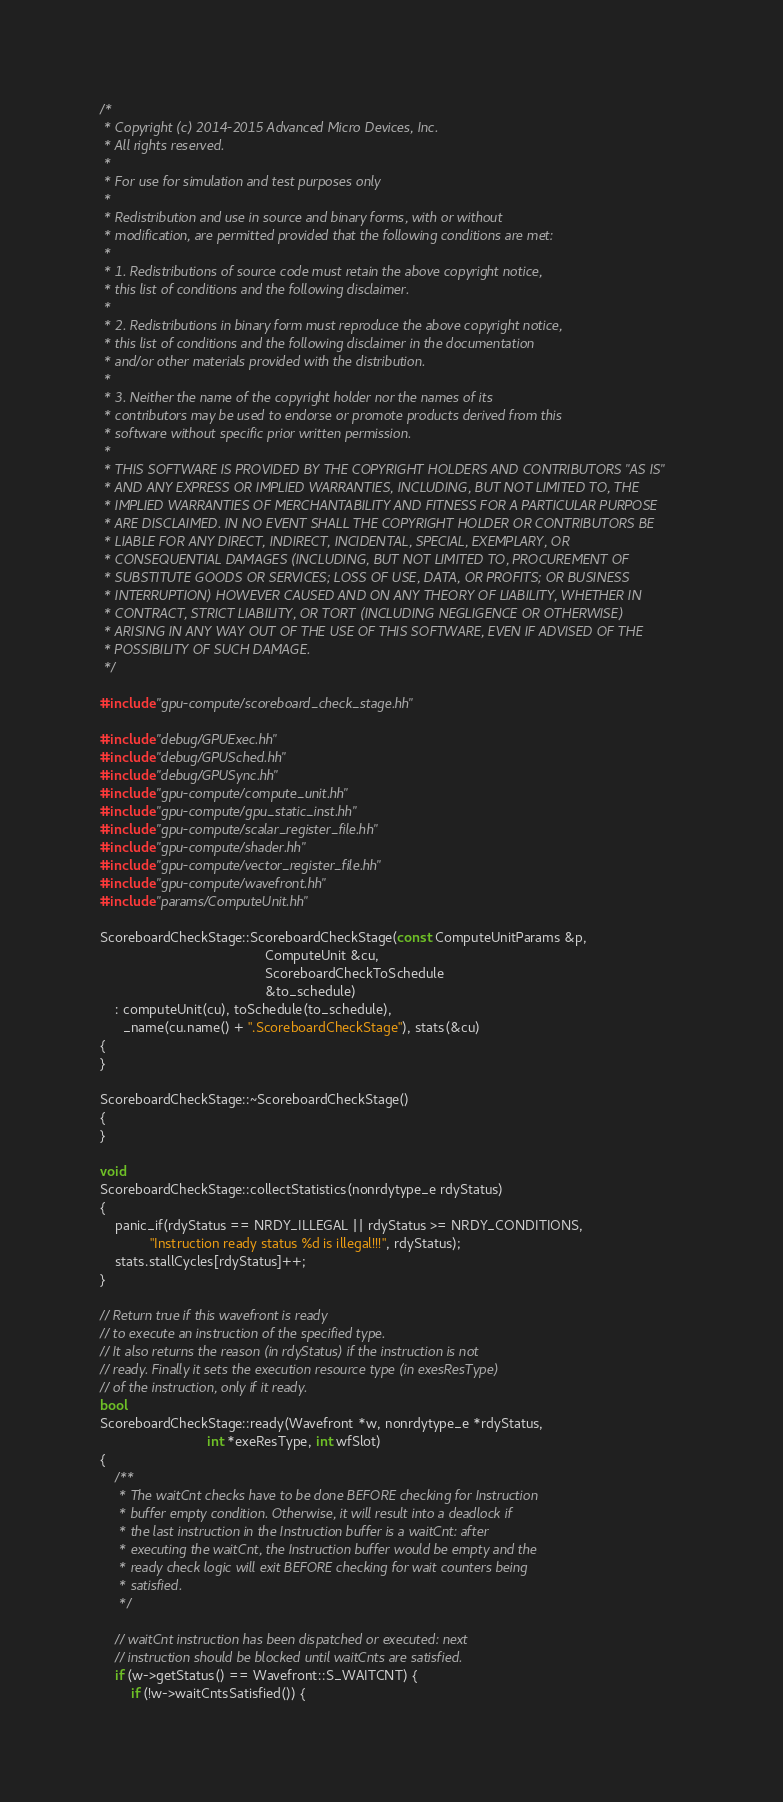Convert code to text. <code><loc_0><loc_0><loc_500><loc_500><_C++_>/*
 * Copyright (c) 2014-2015 Advanced Micro Devices, Inc.
 * All rights reserved.
 *
 * For use for simulation and test purposes only
 *
 * Redistribution and use in source and binary forms, with or without
 * modification, are permitted provided that the following conditions are met:
 *
 * 1. Redistributions of source code must retain the above copyright notice,
 * this list of conditions and the following disclaimer.
 *
 * 2. Redistributions in binary form must reproduce the above copyright notice,
 * this list of conditions and the following disclaimer in the documentation
 * and/or other materials provided with the distribution.
 *
 * 3. Neither the name of the copyright holder nor the names of its
 * contributors may be used to endorse or promote products derived from this
 * software without specific prior written permission.
 *
 * THIS SOFTWARE IS PROVIDED BY THE COPYRIGHT HOLDERS AND CONTRIBUTORS "AS IS"
 * AND ANY EXPRESS OR IMPLIED WARRANTIES, INCLUDING, BUT NOT LIMITED TO, THE
 * IMPLIED WARRANTIES OF MERCHANTABILITY AND FITNESS FOR A PARTICULAR PURPOSE
 * ARE DISCLAIMED. IN NO EVENT SHALL THE COPYRIGHT HOLDER OR CONTRIBUTORS BE
 * LIABLE FOR ANY DIRECT, INDIRECT, INCIDENTAL, SPECIAL, EXEMPLARY, OR
 * CONSEQUENTIAL DAMAGES (INCLUDING, BUT NOT LIMITED TO, PROCUREMENT OF
 * SUBSTITUTE GOODS OR SERVICES; LOSS OF USE, DATA, OR PROFITS; OR BUSINESS
 * INTERRUPTION) HOWEVER CAUSED AND ON ANY THEORY OF LIABILITY, WHETHER IN
 * CONTRACT, STRICT LIABILITY, OR TORT (INCLUDING NEGLIGENCE OR OTHERWISE)
 * ARISING IN ANY WAY OUT OF THE USE OF THIS SOFTWARE, EVEN IF ADVISED OF THE
 * POSSIBILITY OF SUCH DAMAGE.
 */

#include "gpu-compute/scoreboard_check_stage.hh"

#include "debug/GPUExec.hh"
#include "debug/GPUSched.hh"
#include "debug/GPUSync.hh"
#include "gpu-compute/compute_unit.hh"
#include "gpu-compute/gpu_static_inst.hh"
#include "gpu-compute/scalar_register_file.hh"
#include "gpu-compute/shader.hh"
#include "gpu-compute/vector_register_file.hh"
#include "gpu-compute/wavefront.hh"
#include "params/ComputeUnit.hh"

ScoreboardCheckStage::ScoreboardCheckStage(const ComputeUnitParams &p,
                                           ComputeUnit &cu,
                                           ScoreboardCheckToSchedule
                                           &to_schedule)
    : computeUnit(cu), toSchedule(to_schedule),
      _name(cu.name() + ".ScoreboardCheckStage"), stats(&cu)
{
}

ScoreboardCheckStage::~ScoreboardCheckStage()
{
}

void
ScoreboardCheckStage::collectStatistics(nonrdytype_e rdyStatus)
{
    panic_if(rdyStatus == NRDY_ILLEGAL || rdyStatus >= NRDY_CONDITIONS,
             "Instruction ready status %d is illegal!!!", rdyStatus);
    stats.stallCycles[rdyStatus]++;
}

// Return true if this wavefront is ready
// to execute an instruction of the specified type.
// It also returns the reason (in rdyStatus) if the instruction is not
// ready. Finally it sets the execution resource type (in exesResType)
// of the instruction, only if it ready.
bool
ScoreboardCheckStage::ready(Wavefront *w, nonrdytype_e *rdyStatus,
                            int *exeResType, int wfSlot)
{
    /**
     * The waitCnt checks have to be done BEFORE checking for Instruction
     * buffer empty condition. Otherwise, it will result into a deadlock if
     * the last instruction in the Instruction buffer is a waitCnt: after
     * executing the waitCnt, the Instruction buffer would be empty and the
     * ready check logic will exit BEFORE checking for wait counters being
     * satisfied.
     */

    // waitCnt instruction has been dispatched or executed: next
    // instruction should be blocked until waitCnts are satisfied.
    if (w->getStatus() == Wavefront::S_WAITCNT) {
        if (!w->waitCntsSatisfied()) {</code> 